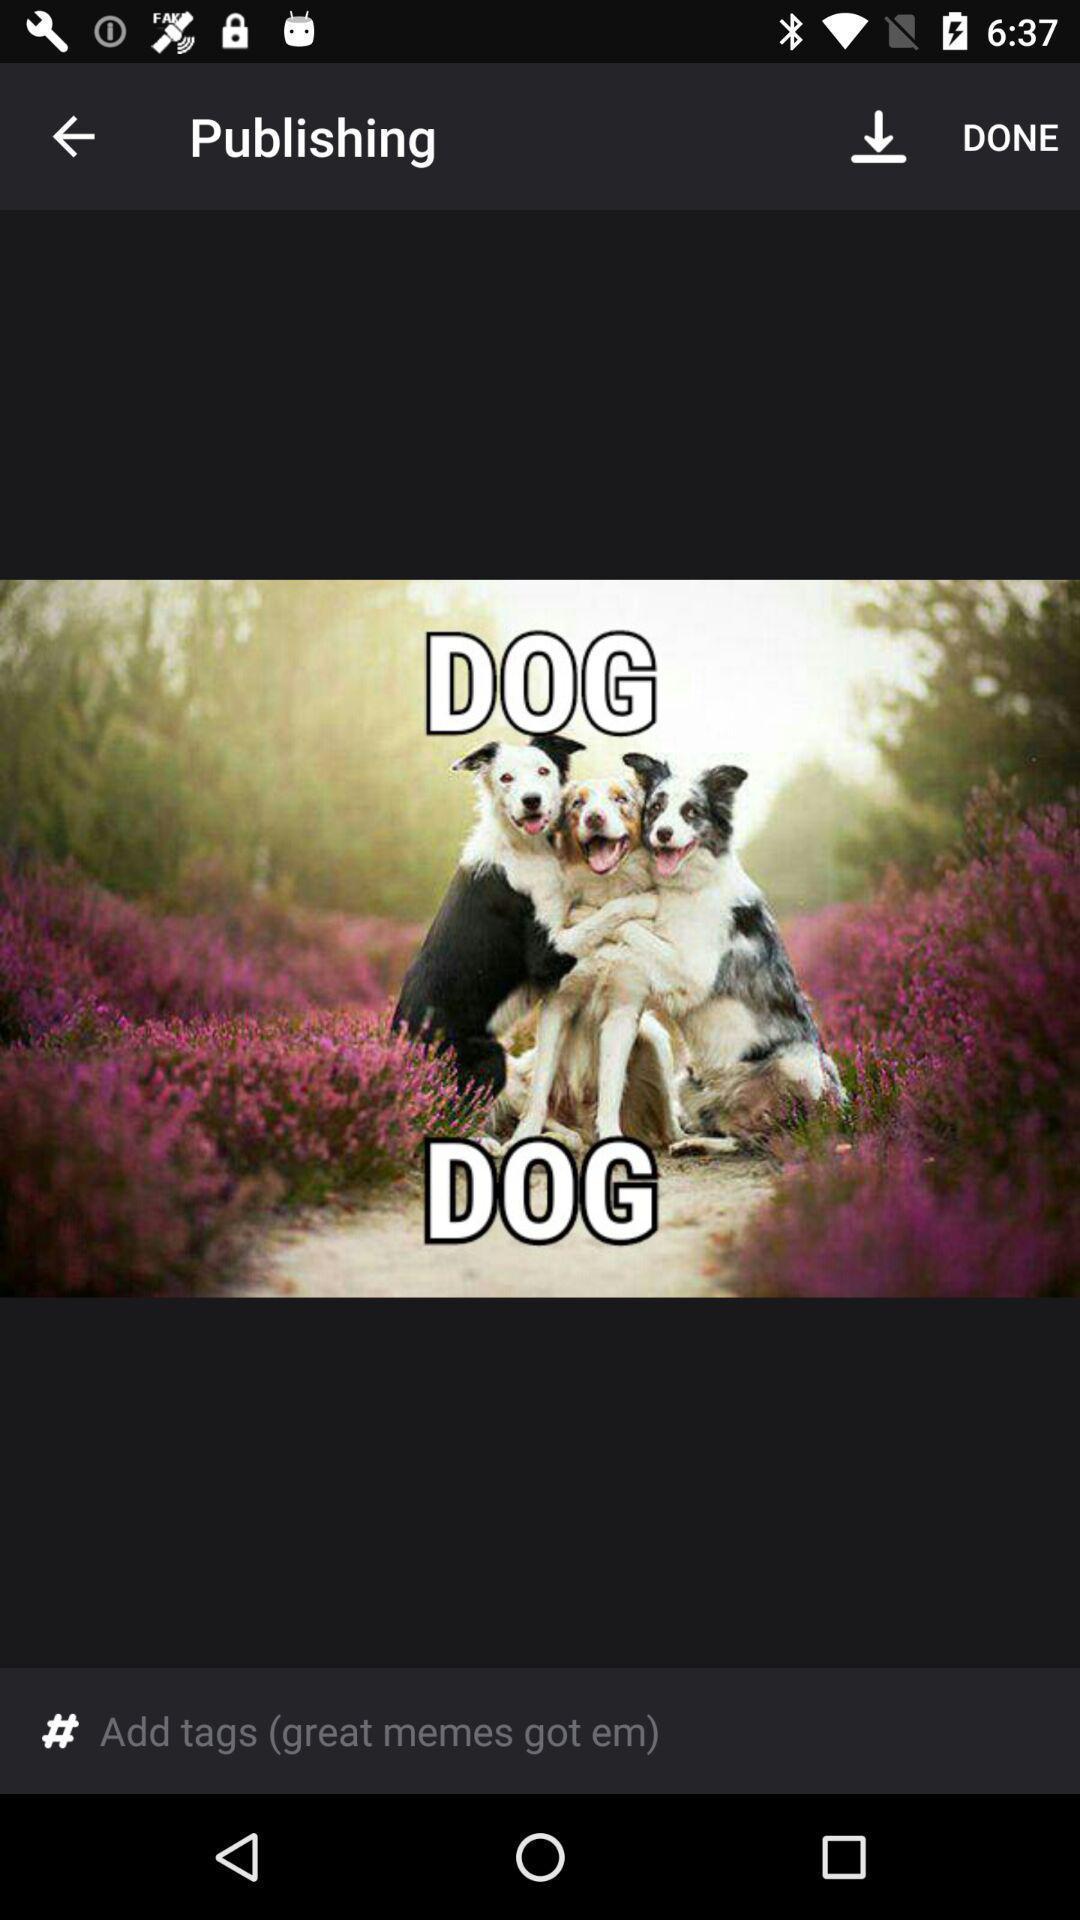Tell me what you see in this picture. Page showing the image for publishing. 